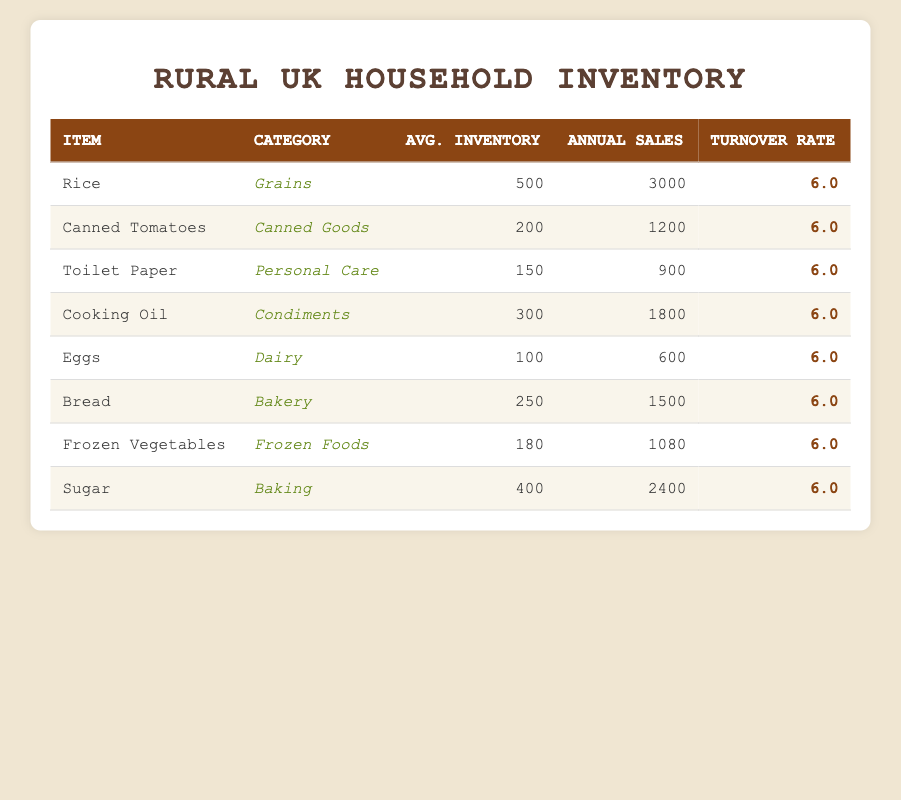What is the average inventory level of all items listed? To find the average inventory level, we sum the average inventory levels of all items: 500 + 200 + 150 + 300 + 100 + 250 + 180 + 400 = 2080. There are 8 items, so the average is 2080 / 8 = 260.
Answer: 260 Which item has the lowest annual sales quantity? By reviewing the annual sales quantity column, we identify that Eggs has the lowest sales quantity at 600.
Answer: Eggs Is the inventory turnover rate the same for all items? Looking at the turnover rate column, we see that each item has an inventory turnover rate of 6.0, indicating consistency across the inventory.
Answer: Yes What is the total annual sales quantity for Grains category items? The Grains category includes only Rice, which has an annual sales quantity of 3000. Since there's only one item, the total annual sales for Grains is equal to 3000.
Answer: 3000 If you combine the average inventory levels of Dairy and Bakery categories, what is the total? The average inventory for Dairy (Eggs) is 100 and for Bakery (Bread) is 250. Adding these together gives 100 + 250 = 350.
Answer: 350 How many items have an average inventory level over 250? The items with an average inventory above 250 are Rice (500), Cooking Oil (300), and Sugar (400). This gives us a total of 3 items.
Answer: 3 What is the inventory turnover rate for a product in the Frozen Foods category? Looking at the Frozen Foods category, Frozen Vegetables has an inventory turnover rate of 6.0 as listed in the turnover rate column.
Answer: 6.0 Which category does the item with the maximum average inventory belong to? The item with the maximum average inventory is Rice, which belongs to the Grains category with an average inventory of 500.
Answer: Grains What would be the total average inventory level if we exclude the item with the lowest annual sales? Excluding Eggs (100), we add the average inventory levels of the remaining items: 500 + 200 + 150 + 300 + 250 + 180 + 400 = 1980. There are now 7 items, so the new average is 1980 / 7 = approximately 283.
Answer: 283 